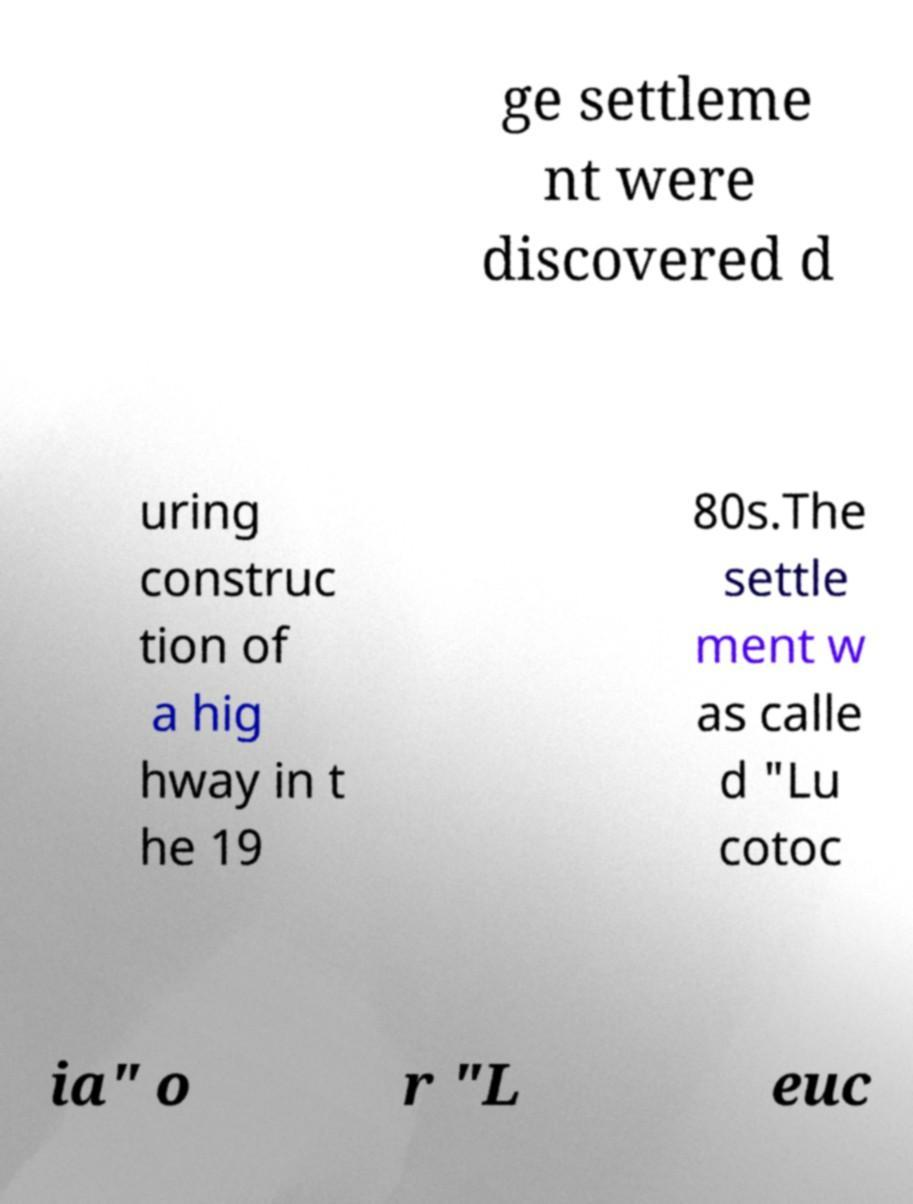For documentation purposes, I need the text within this image transcribed. Could you provide that? ge settleme nt were discovered d uring construc tion of a hig hway in t he 19 80s.The settle ment w as calle d "Lu cotoc ia" o r "L euc 